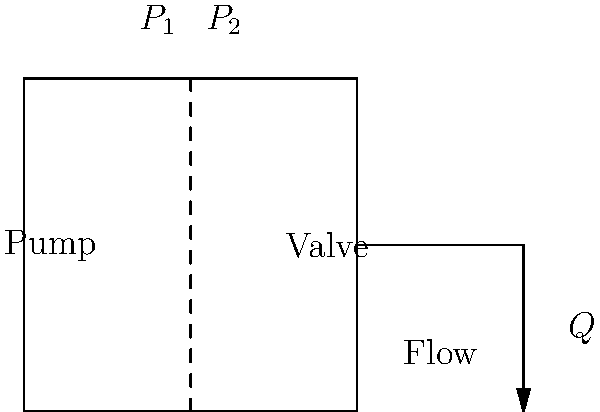In your factory's hydraulic system, a pump generates a pressure $P_1 = 200$ kPa, which is reduced to $P_2 = 150$ kPa after passing through a control valve. The system operates with a flow rate $Q = 0.05$ m³/s. Assuming no energy losses other than at the valve, calculate the power dissipated by the valve. How might this information influence your decision-making regarding equipment maintenance and energy efficiency in your factory? To solve this problem, we'll follow these steps:

1) The power dissipated by the valve is equal to the difference in hydraulic power before and after the valve.

2) Hydraulic power is calculated using the formula:
   $$P = pQ$$
   where $P$ is power (in watts), $p$ is pressure (in pascals), and $Q$ is flow rate (in m³/s).

3) Calculate the hydraulic power before the valve:
   $$P_1 = p_1Q = 200,000 \text{ Pa} \times 0.05 \text{ m³/s} = 10,000 \text{ W} = 10 \text{ kW}$$

4) Calculate the hydraulic power after the valve:
   $$P_2 = p_2Q = 150,000 \text{ Pa} \times 0.05 \text{ m³/s} = 7,500 \text{ W} = 7.5 \text{ kW}$$

5) The power dissipated by the valve is the difference:
   $$P_{\text{dissipated}} = P_1 - P_2 = 10 \text{ kW} - 7.5 \text{ kW} = 2.5 \text{ kW}$$

This information is crucial for decision-making regarding equipment maintenance and energy efficiency:

1) The 2.5 kW power loss represents wasted energy, which translates to increased operational costs.
2) Regular maintenance of the valve could minimize this power loss, improving overall system efficiency.
3) Upgrading to a more efficient valve could lead to long-term cost savings.
4) This analysis can be applied to other components in the factory to identify areas for potential energy savings.
Answer: 2.5 kW 